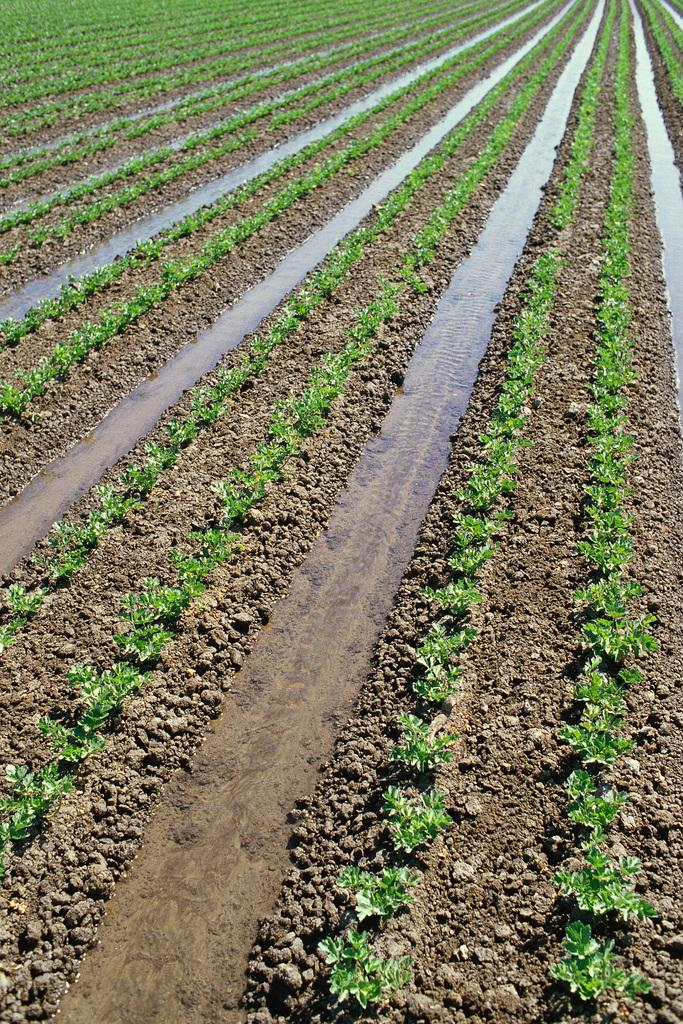Where was the image taken? The image is taken outdoors. What can be seen on the ground in the image? There are many plants and a few water puddles on the ground. How many cherries are on the ground in the image? There are no cherries present in the image. Are there any children playing in the water puddles in the image? There is no mention of children in the image, and the focus is on the plants and water puddles. 